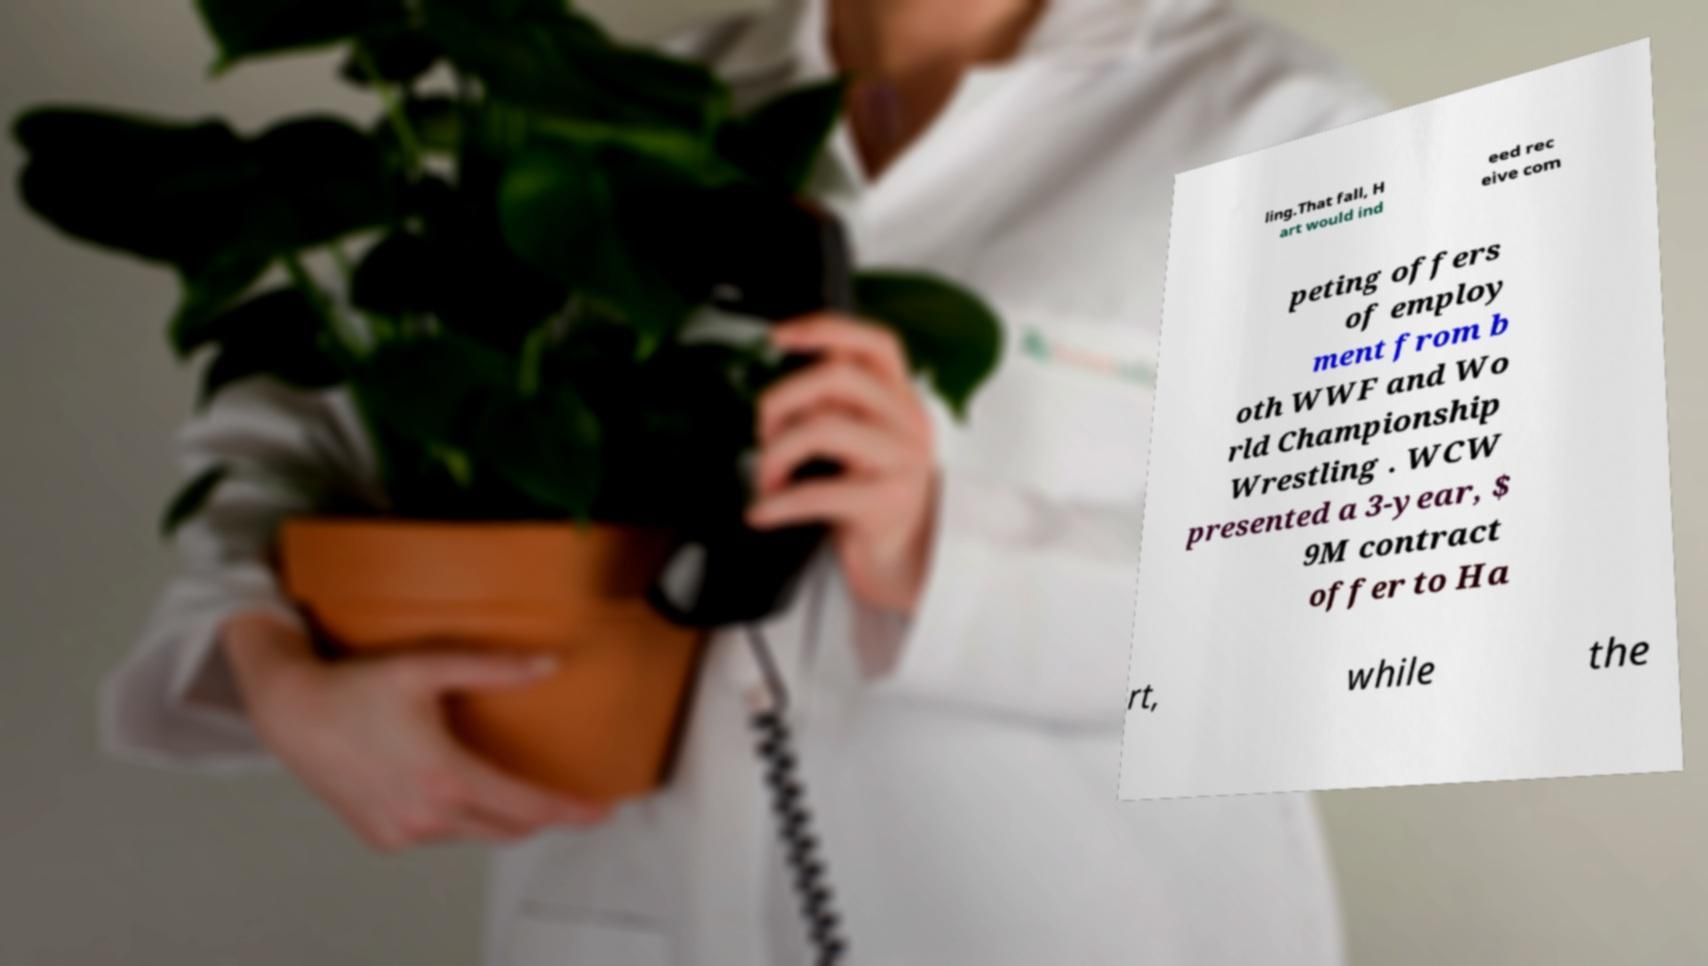For documentation purposes, I need the text within this image transcribed. Could you provide that? ling.That fall, H art would ind eed rec eive com peting offers of employ ment from b oth WWF and Wo rld Championship Wrestling . WCW presented a 3-year, $ 9M contract offer to Ha rt, while the 